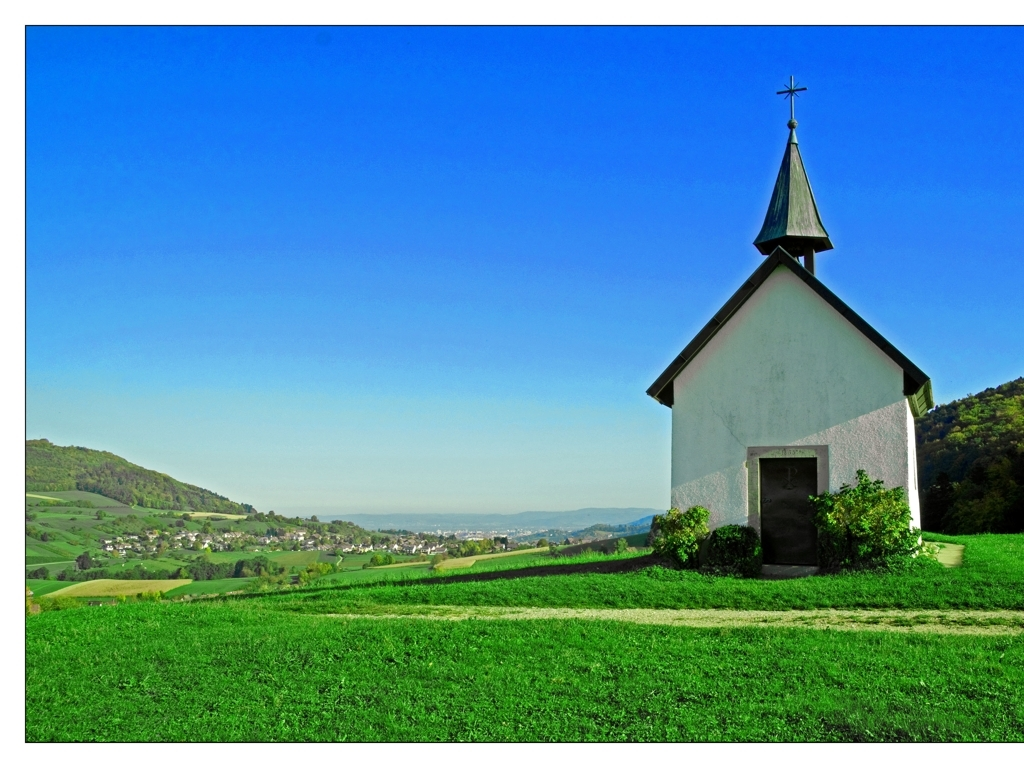Can you describe the architecture of the building? Certainly. The building is a small chapel with simple, traditional architecture. It has a white plaster facade, a symmetrically pitched roof, and a modest steeple with a cross at its peak. The entrance appears to be unadorned except for the dark doorway, which provides a stark contrast to the white walls. 